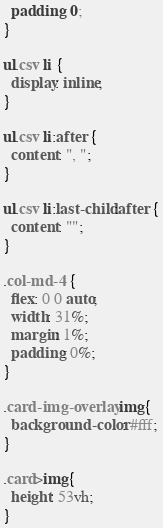<code> <loc_0><loc_0><loc_500><loc_500><_CSS_>  padding: 0;
}

ul.csv li {
  display: inline;
}

ul.csv li:after {
  content: ", ";
}

ul.csv li:last-child:after {
  content: "";
}

.col-md-4 {
  flex: 0 0 auto;
  width: 31%;
  margin: 1%;
  padding: 0%;
}

.card-img-overlay img{
  background-color: #fff;
}

.card>img{
  height: 53vh;
}
</code> 